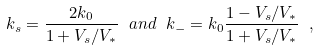Convert formula to latex. <formula><loc_0><loc_0><loc_500><loc_500>k _ { s } = \frac { 2 k _ { 0 } } { 1 + V _ { s } / V _ { * } } \ a n d \ k _ { - } = k _ { 0 } \frac { 1 - V _ { s } / V _ { * } } { 1 + V _ { s } / V _ { * } } \ ,</formula> 